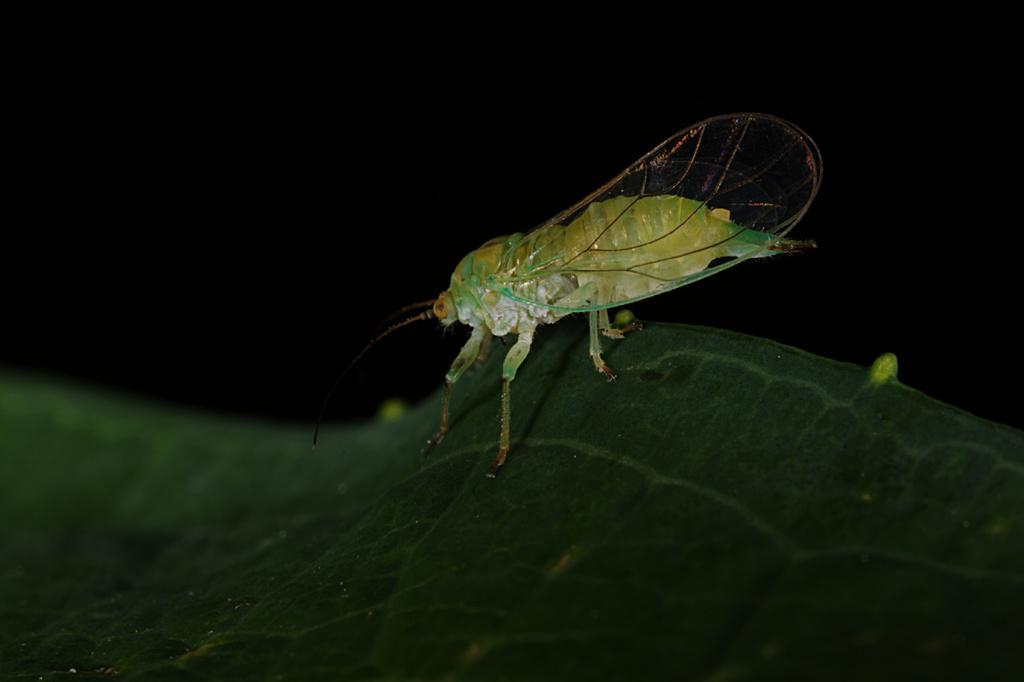What is located on the leaf in the image? There is an insect on a leaf in the image. What can be seen in the background of the image? The background of the image is black. What type of screw can be seen in the image? There is no screw present in the image; it features an insect on a leaf with a black background. What type of respect is being shown in the image? The image does not depict any form of respect; it features an insect on a leaf with a black background. 